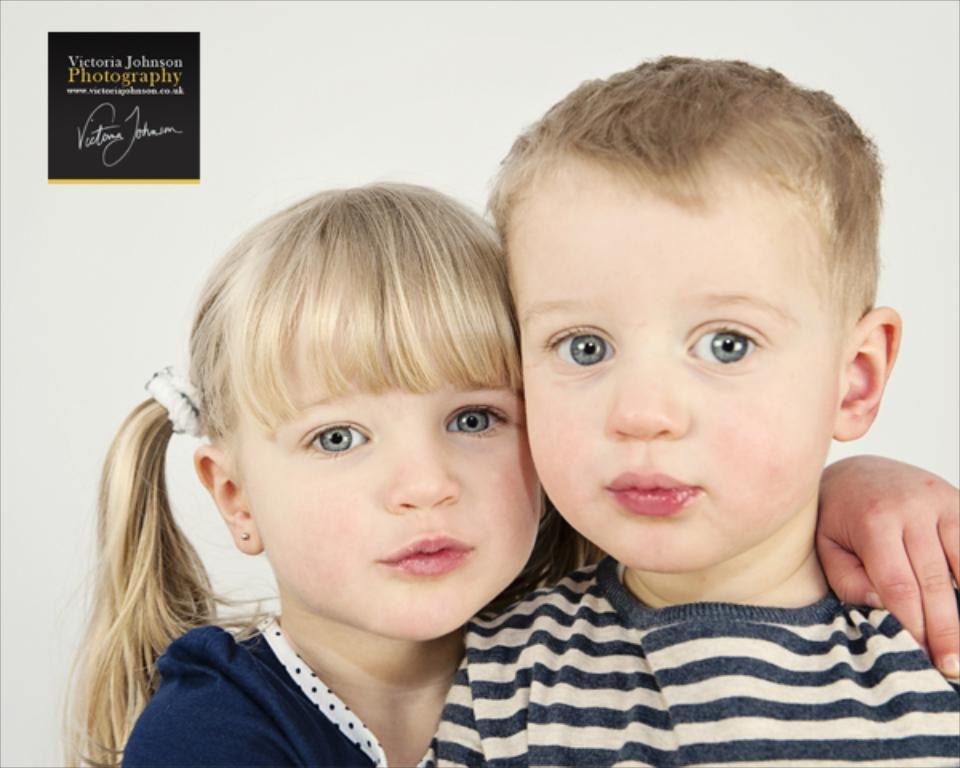What is the color of the wall in the image? The wall in the image is white. How many people are visible in the image? There are two people standing in the front of the image. Can you see the worm crawling on the wall in the image? There is no worm present in the image; it only showcases a white wall and two people standing in front of it. 